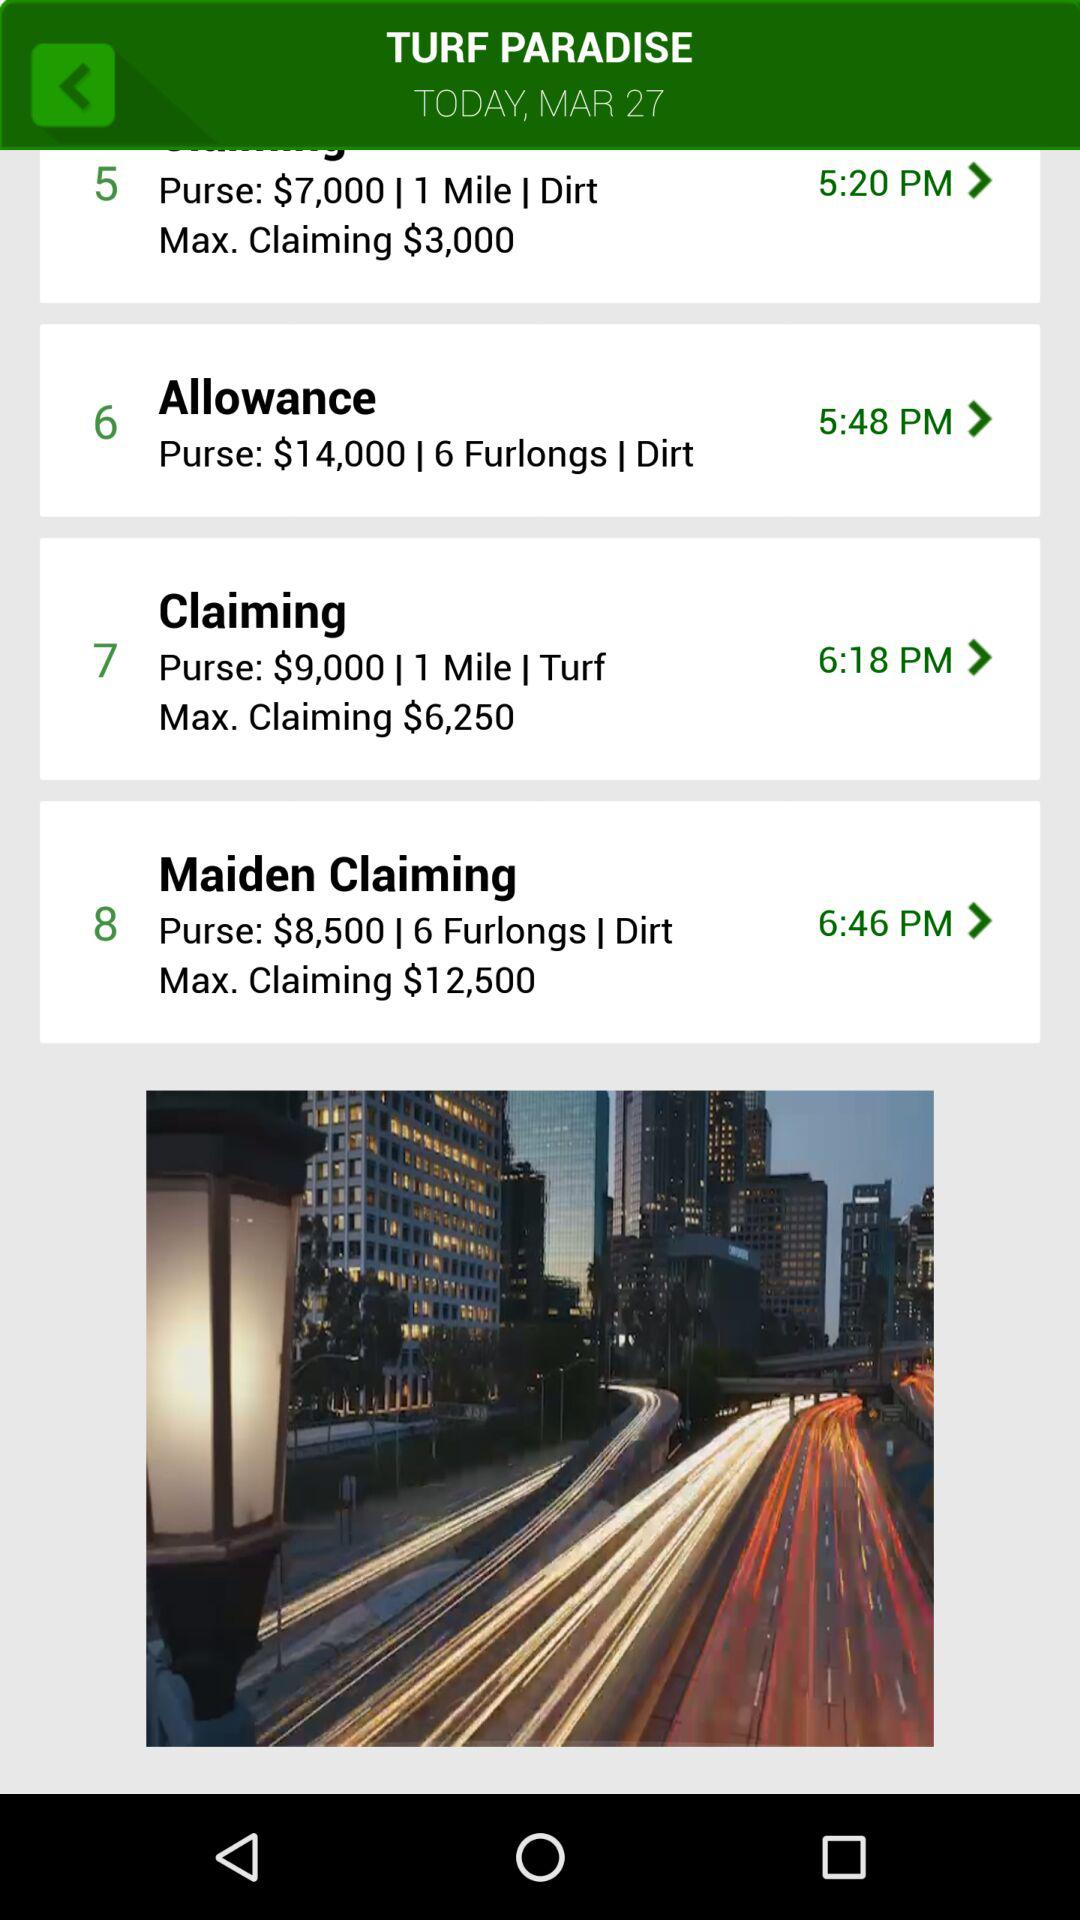What is today's date? The date is March 27. 